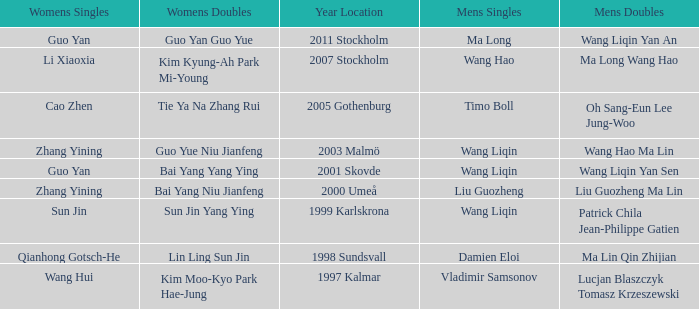How many times has Ma Long won the men's singles? 1.0. 